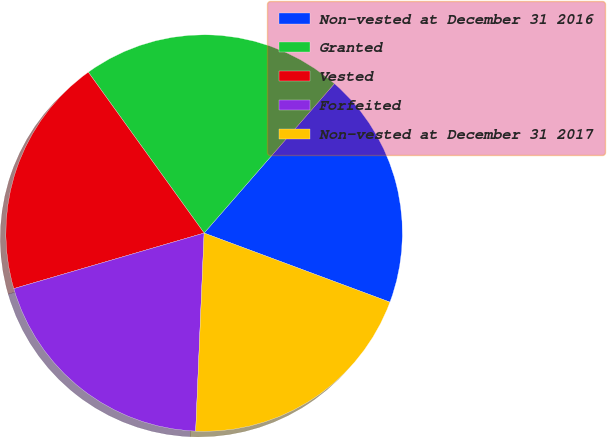<chart> <loc_0><loc_0><loc_500><loc_500><pie_chart><fcel>Non-vested at December 31 2016<fcel>Granted<fcel>Vested<fcel>Forfeited<fcel>Non-vested at December 31 2017<nl><fcel>19.25%<fcel>21.34%<fcel>19.59%<fcel>19.8%<fcel>20.01%<nl></chart> 